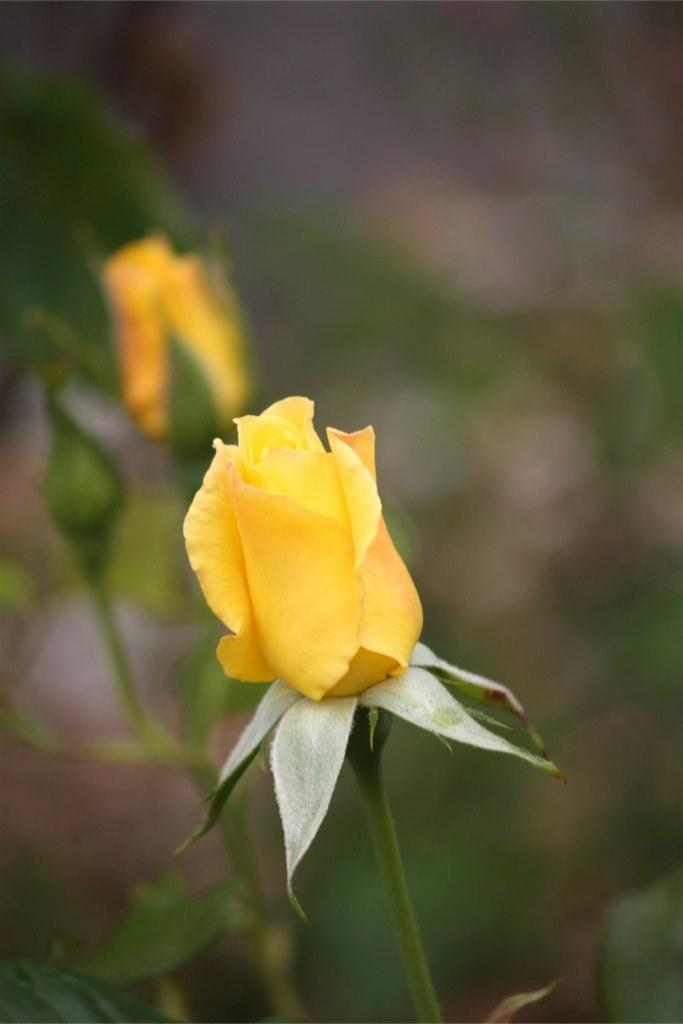What type of flowers are in the center of the image? There are rose flowers in the center of the image. What else can be seen in the image besides the flowers? Leaves are present in the image. How would you describe the background of the image? The background of the image is blurry. Can you see the farmer's toes in the image? There is no farmer or toes present in the image; it features rose flowers and leaves. What type of dog is sitting next to the rose flowers in the image? There is no dog present in the image; it only features rose flowers and leaves. 